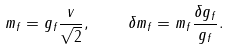Convert formula to latex. <formula><loc_0><loc_0><loc_500><loc_500>m _ { f } = g _ { f } \frac { v } { \sqrt { 2 } } , \quad \delta m _ { f } = m _ { f } \frac { \delta g _ { f } } { g _ { f } } .</formula> 